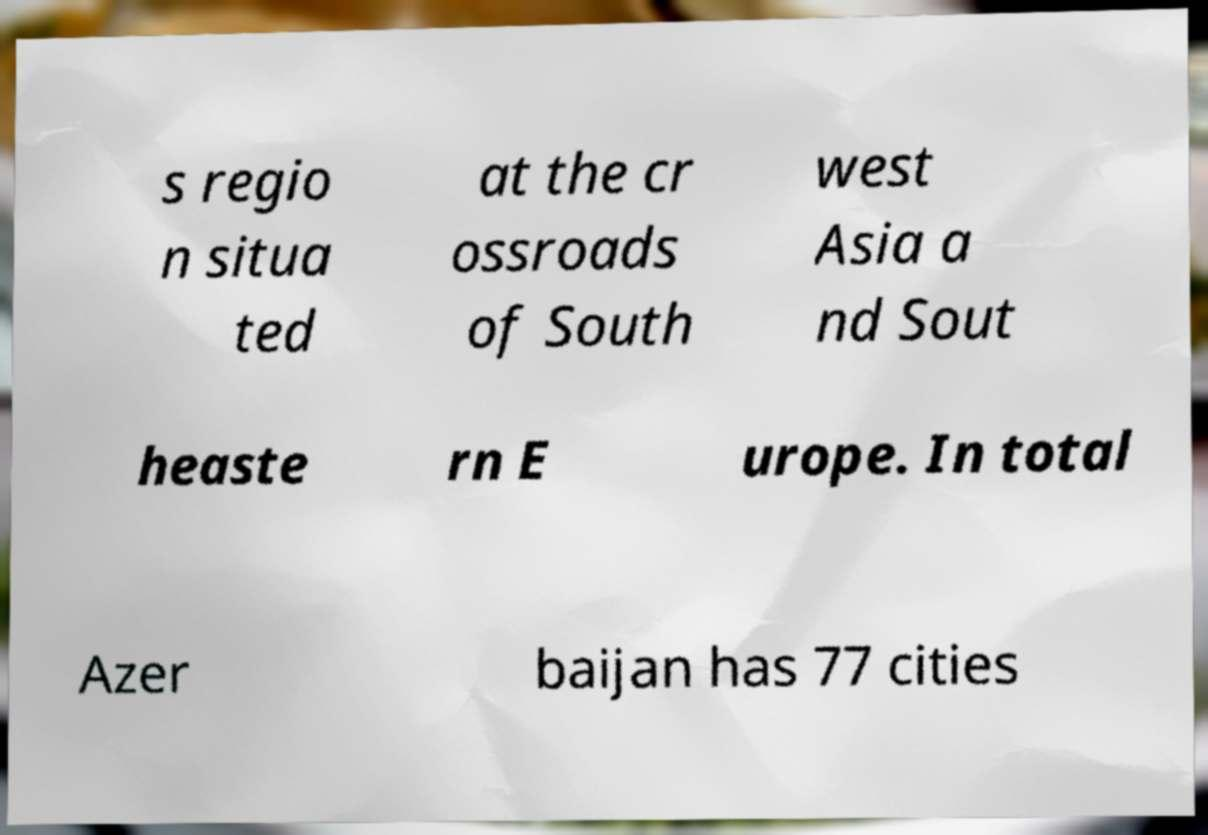There's text embedded in this image that I need extracted. Can you transcribe it verbatim? s regio n situa ted at the cr ossroads of South west Asia a nd Sout heaste rn E urope. In total Azer baijan has 77 cities 